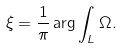<formula> <loc_0><loc_0><loc_500><loc_500>\xi = \frac { 1 } { \pi } \arg \int _ { L } \Omega .</formula> 